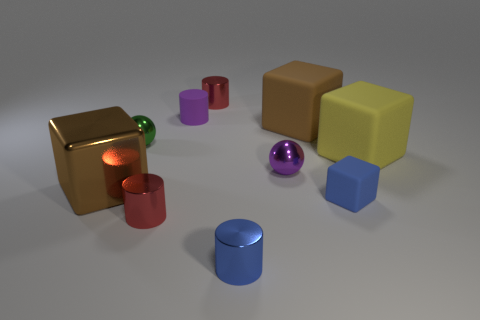Subtract 1 blocks. How many blocks are left? 3 Subtract all purple blocks. Subtract all green spheres. How many blocks are left? 4 Subtract all cylinders. How many objects are left? 6 Subtract all spheres. Subtract all tiny blue metallic cylinders. How many objects are left? 7 Add 6 brown metallic cubes. How many brown metallic cubes are left? 7 Add 2 small green matte things. How many small green matte things exist? 2 Subtract 0 cyan balls. How many objects are left? 10 